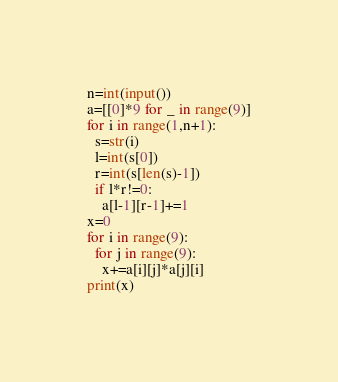Convert code to text. <code><loc_0><loc_0><loc_500><loc_500><_Python_>n=int(input())
a=[[0]*9 for _ in range(9)]
for i in range(1,n+1):
  s=str(i)
  l=int(s[0])
  r=int(s[len(s)-1])
  if l*r!=0:
    a[l-1][r-1]+=1
x=0
for i in range(9):
  for j in range(9):
    x+=a[i][j]*a[j][i]
print(x)</code> 